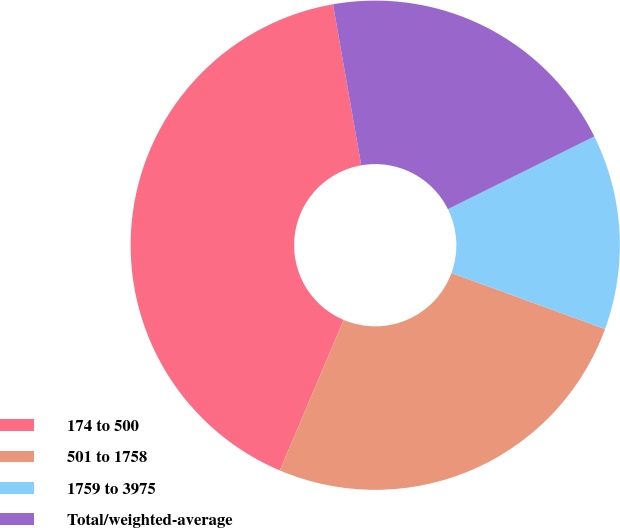Convert chart to OTSL. <chart><loc_0><loc_0><loc_500><loc_500><pie_chart><fcel>174 to 500<fcel>501 to 1758<fcel>1759 to 3975<fcel>Total/weighted-average<nl><fcel>40.86%<fcel>25.81%<fcel>12.9%<fcel>20.43%<nl></chart> 